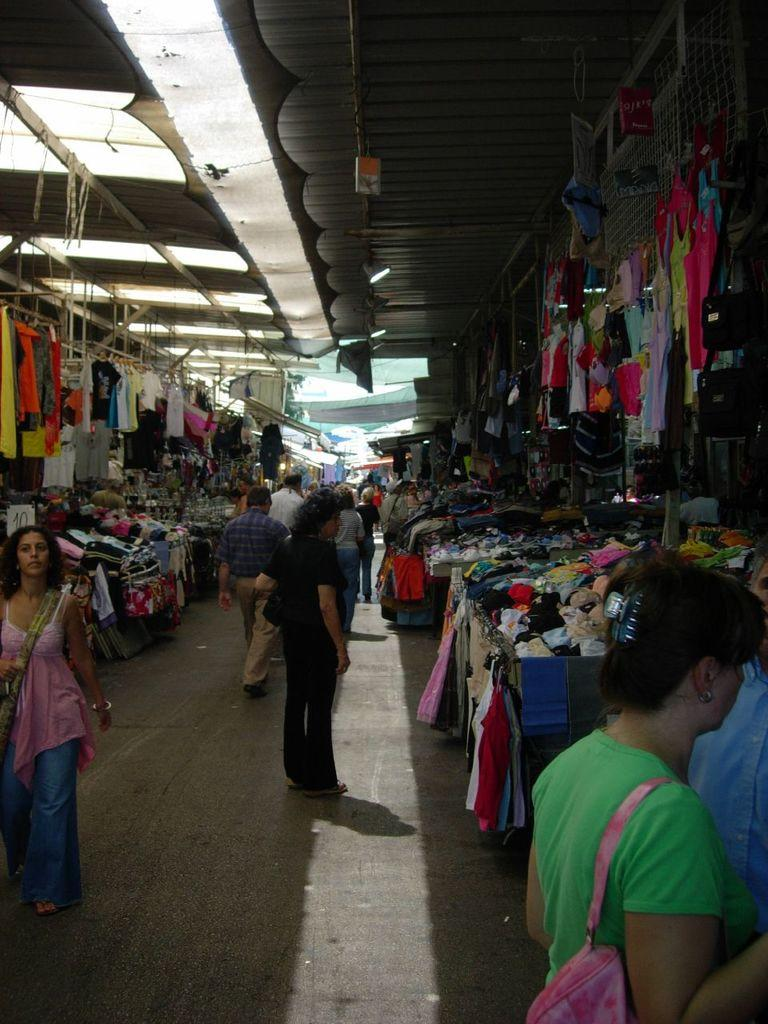What are the people in the image doing? The people in the image are walking on a path. What can be found on either side of the path? There are stalls on either side of the path. What type of items are being sold in the stalls? Clothes are present in the stalls. What structure is visible at the top of the image? There is a shelter visible at the top of the image. What is the hen's desire while walking on the path in the image? There is no hen present in the image, so it is not possible to determine its desires. 